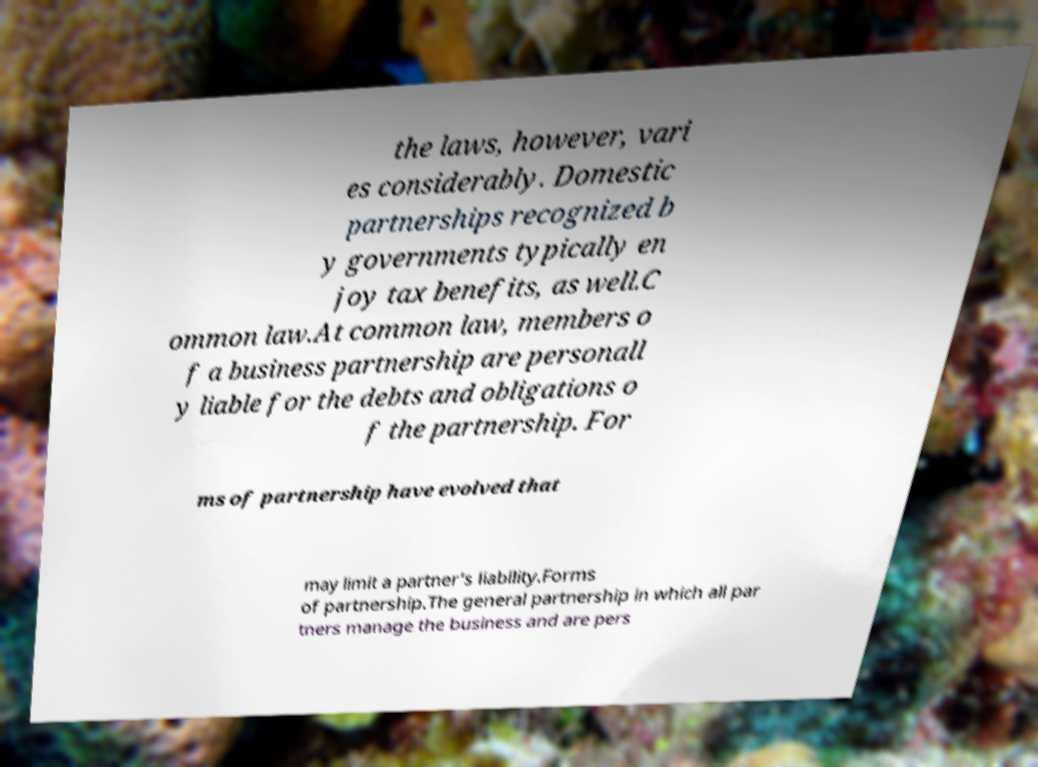What messages or text are displayed in this image? I need them in a readable, typed format. the laws, however, vari es considerably. Domestic partnerships recognized b y governments typically en joy tax benefits, as well.C ommon law.At common law, members o f a business partnership are personall y liable for the debts and obligations o f the partnership. For ms of partnership have evolved that may limit a partner's liability.Forms of partnership.The general partnership in which all par tners manage the business and are pers 